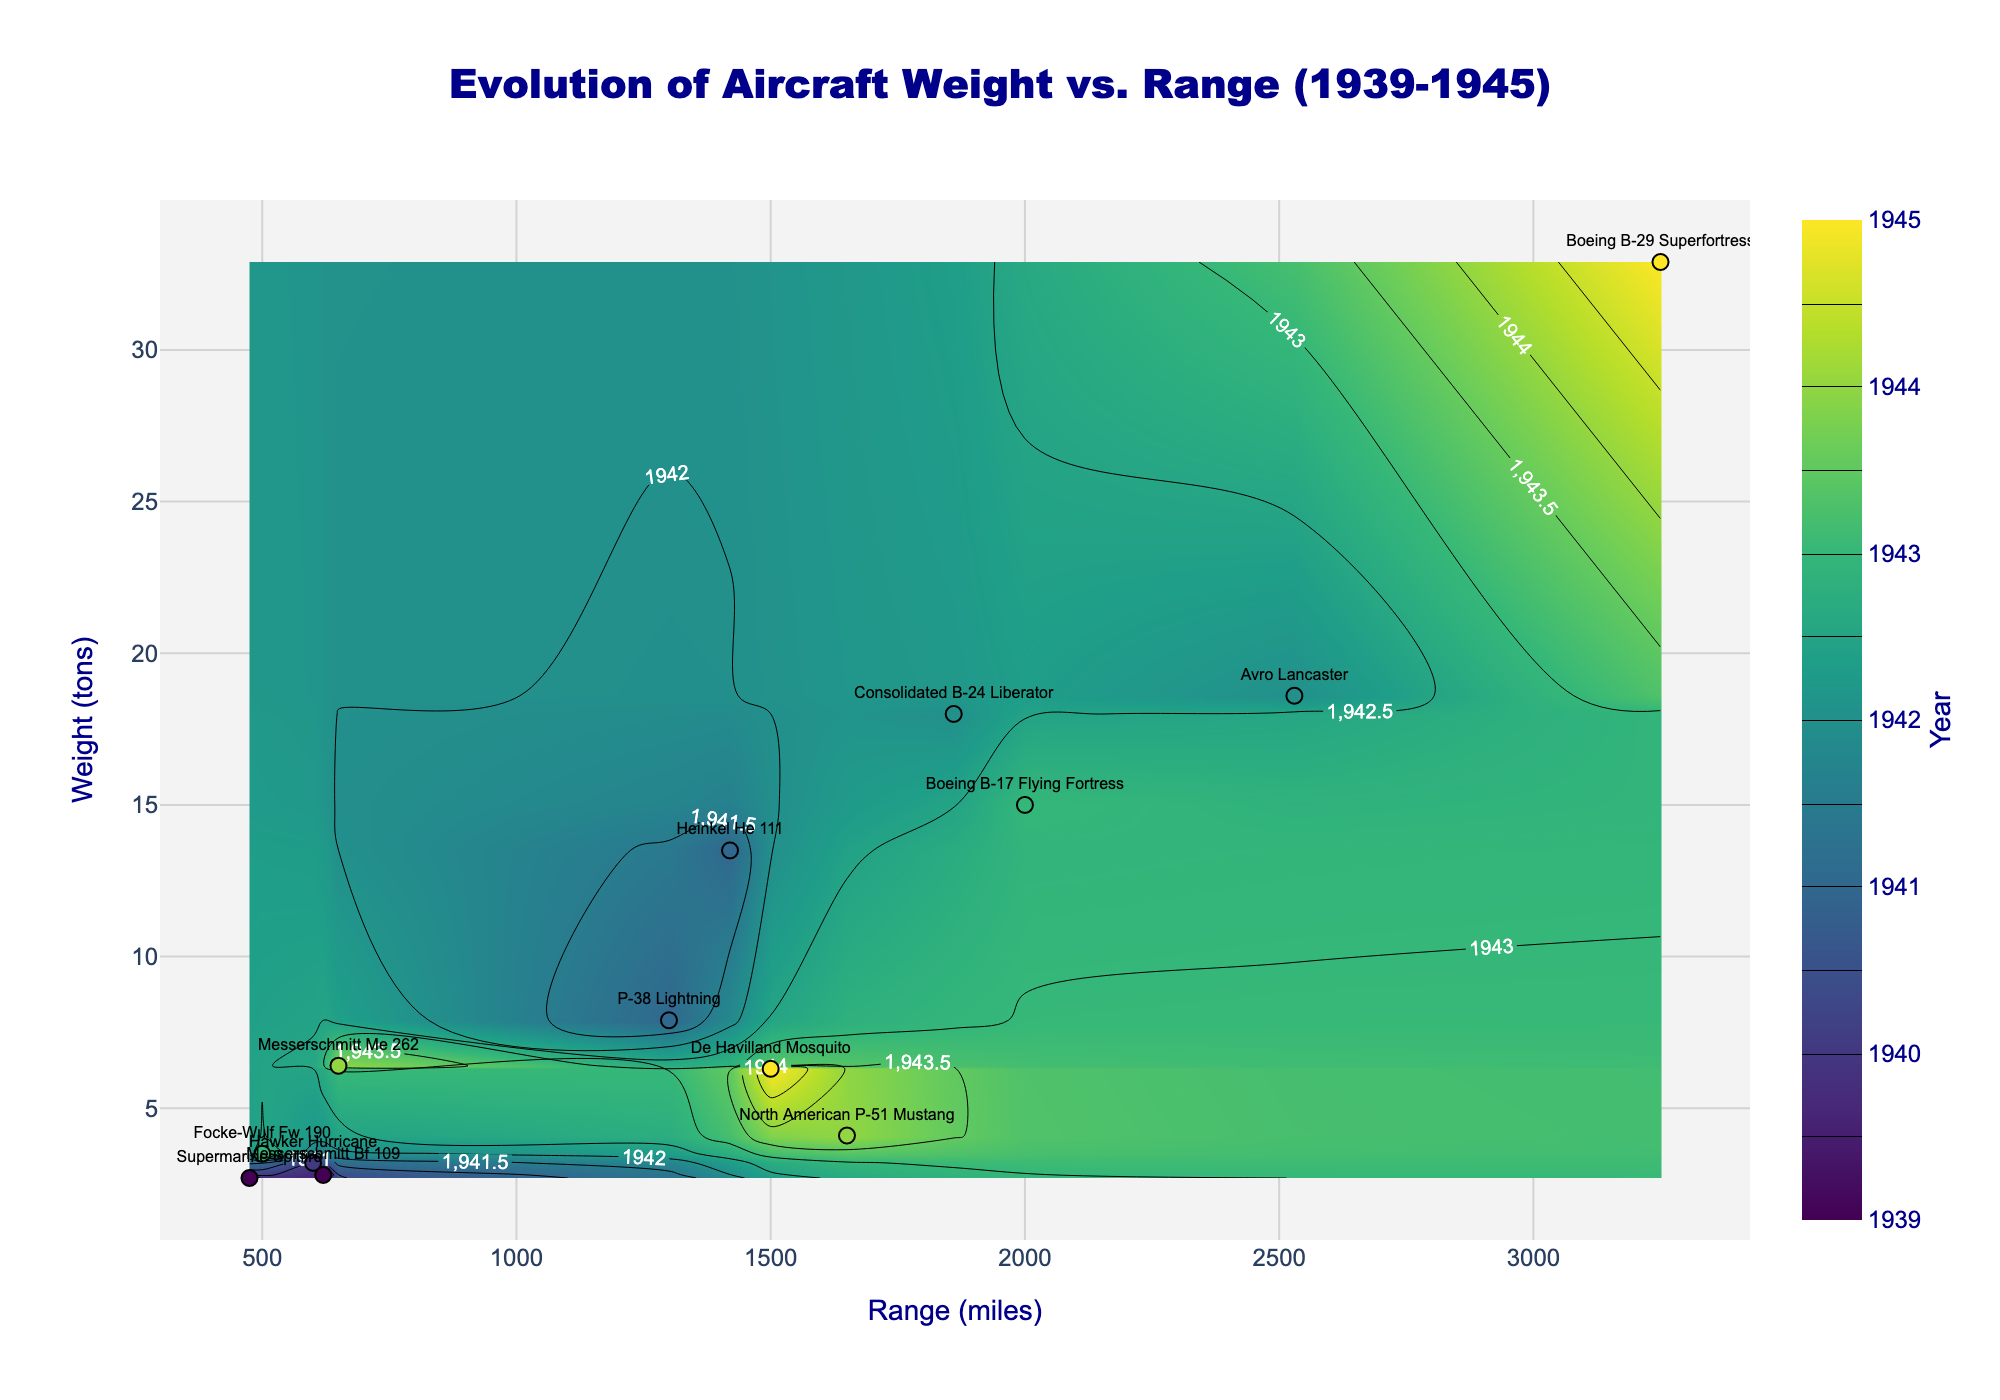What's the title of the plot? The title of the plot is displayed at the top center of the figure.
Answer: Evolution of Aircraft Weight vs. Range (1939-1945) What is the color scale representing in the contour plot? The color scale on the contour plot is labeled on the right-hand side with a color bar.
Answer: Year How many aircraft are listed in the plot? By counting the number of labels scattered in the plot, you can determine the number of aircraft.
Answer: 13 Which aircraft has the largest weight and what is its range? Locate the highest point on the y-axis (weight in tons) and find the associated label and x-value (range).
Answer: Boeing B-29 Superfortress, 3250 miles Which year does the darkest section of the contour plot represent? The darkest color in the 'Viridis' color scale corresponds to the earliest year in the dataset.
Answer: 1939 What is the weight difference between the Avro Lancaster and the Supermarine Spitfire? Determine the weights from the labels and subtract the lower weight from the higher weight. Avro Lancaster (18.6 tons) - Supermarine Spitfire (2.7 tons).
Answer: 15.9 tons Which aircraft has a greater range, the P-38 Lightning or the Messerschmitt Me 262? Locate both aircraft labels on the plot and compare their x-values.
Answer: P-38 Lightning How does the weight of the Boeing B-17 Flying Fortress compare to the De Havilland Mosquito? Compare the y-axis values of both aircraft labels.
Answer: Boeing B-17 Flying Fortress is heavier In which year do we see the first aircraft that has a range greater than 2000 miles? Identify the contour lines and aircraft labels, then check the years.
Answer: 1941 (P-38 Lightning) Which aircraft has an almost equal weight to the North American P-51 Mustang but a different range? Compare the y-values of the North American P-51 Mustang with nearby labels and check their x-values for range differences.
Answer: De Havilland Mosquito 